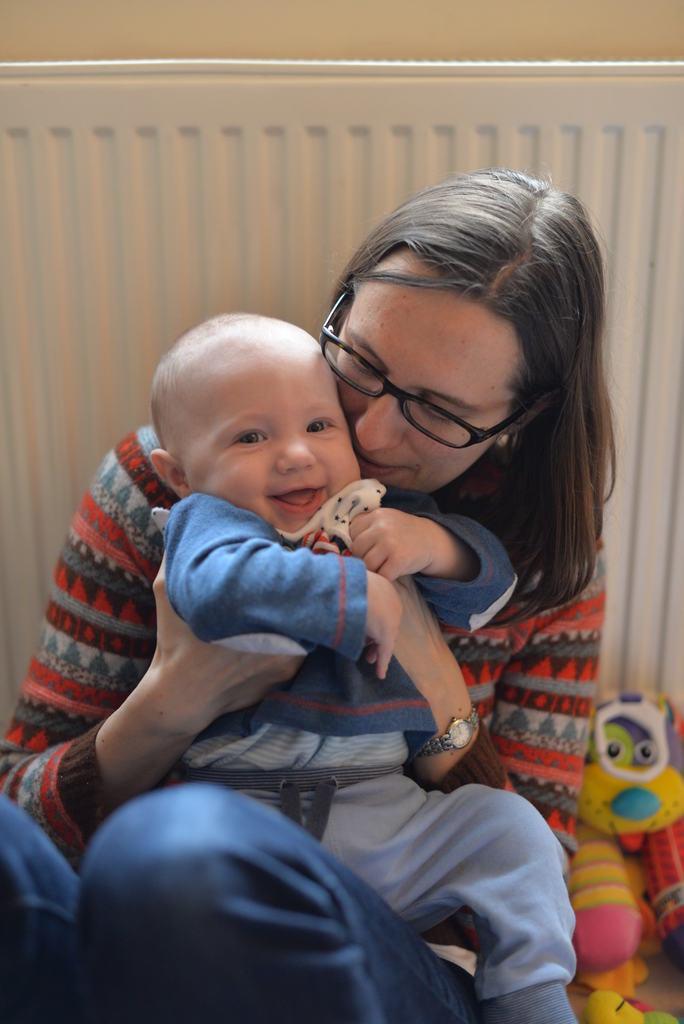In one or two sentences, can you explain what this image depicts? This image is taken indoors. In the background there is a wall. In the middle of the image there is a woman holding a baby in her hands. The baby is with a smiling face. On the right side of the image there are a few toys. 